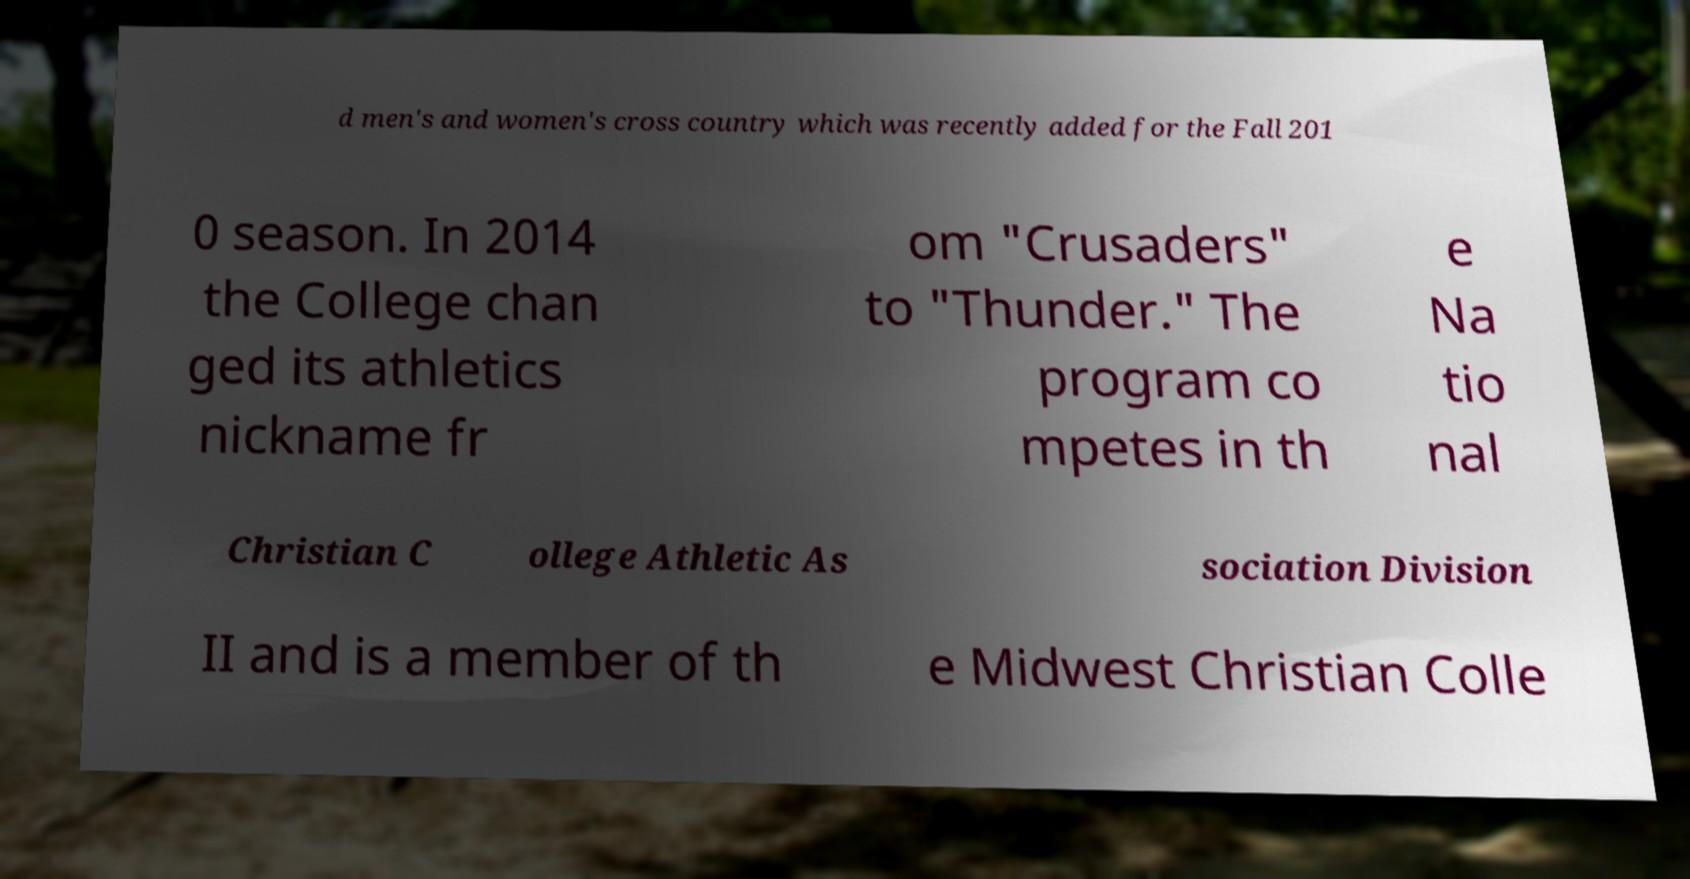I need the written content from this picture converted into text. Can you do that? d men's and women's cross country which was recently added for the Fall 201 0 season. In 2014 the College chan ged its athletics nickname fr om "Crusaders" to "Thunder." The program co mpetes in th e Na tio nal Christian C ollege Athletic As sociation Division II and is a member of th e Midwest Christian Colle 